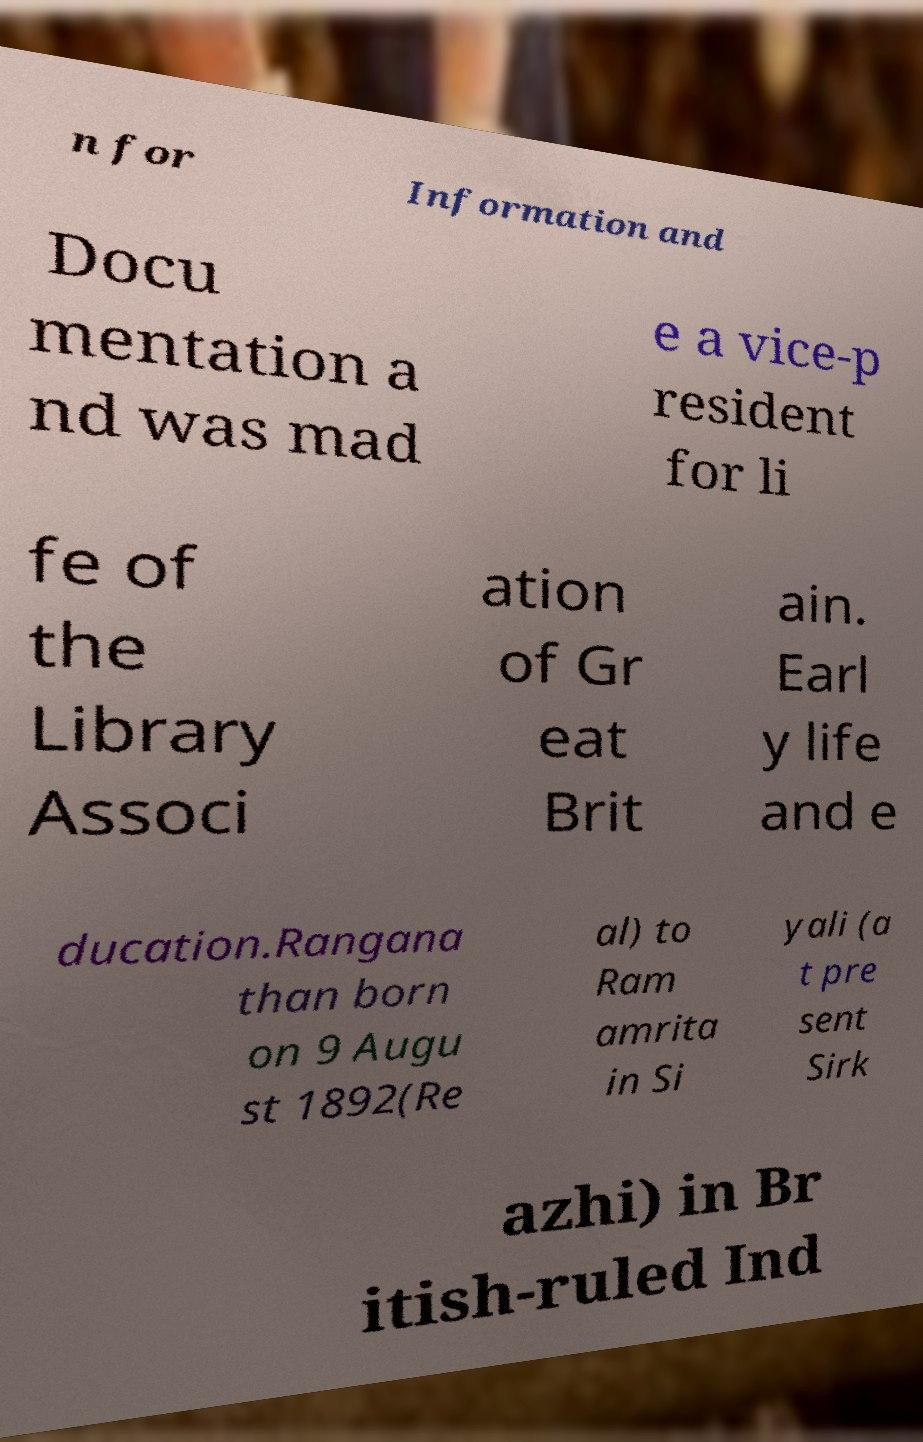What messages or text are displayed in this image? I need them in a readable, typed format. n for Information and Docu mentation a nd was mad e a vice-p resident for li fe of the Library Associ ation of Gr eat Brit ain. Earl y life and e ducation.Rangana than born on 9 Augu st 1892(Re al) to Ram amrita in Si yali (a t pre sent Sirk azhi) in Br itish-ruled Ind 